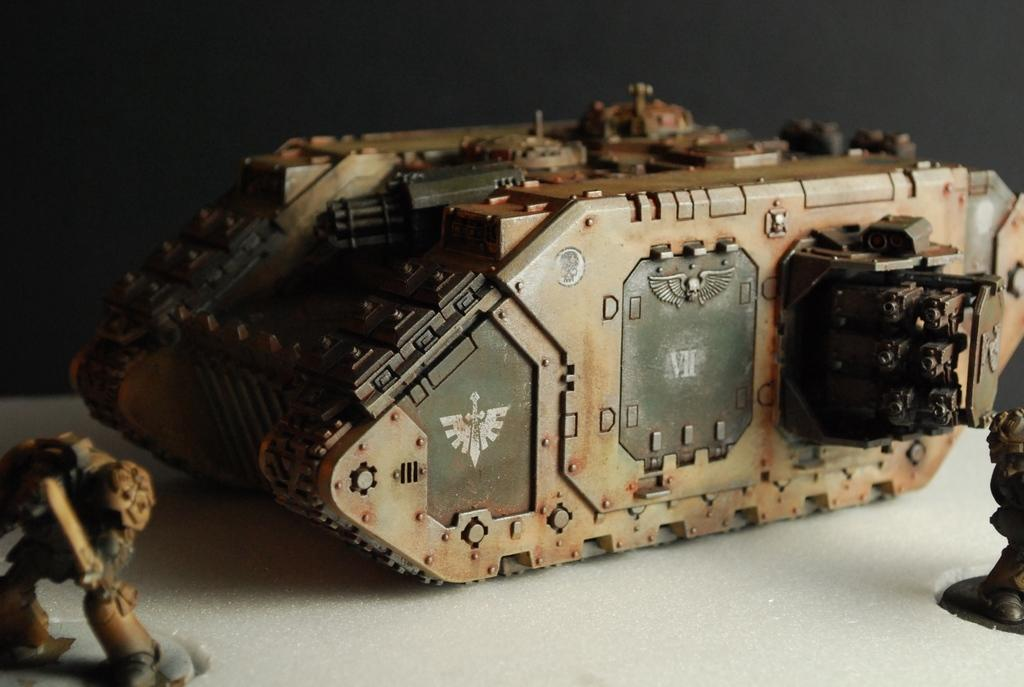What type of objects can be seen in the image? There are toys in the image. What type of lace can be seen on the crib in the image? There is no crib or lace present in the image; it only features toys. 